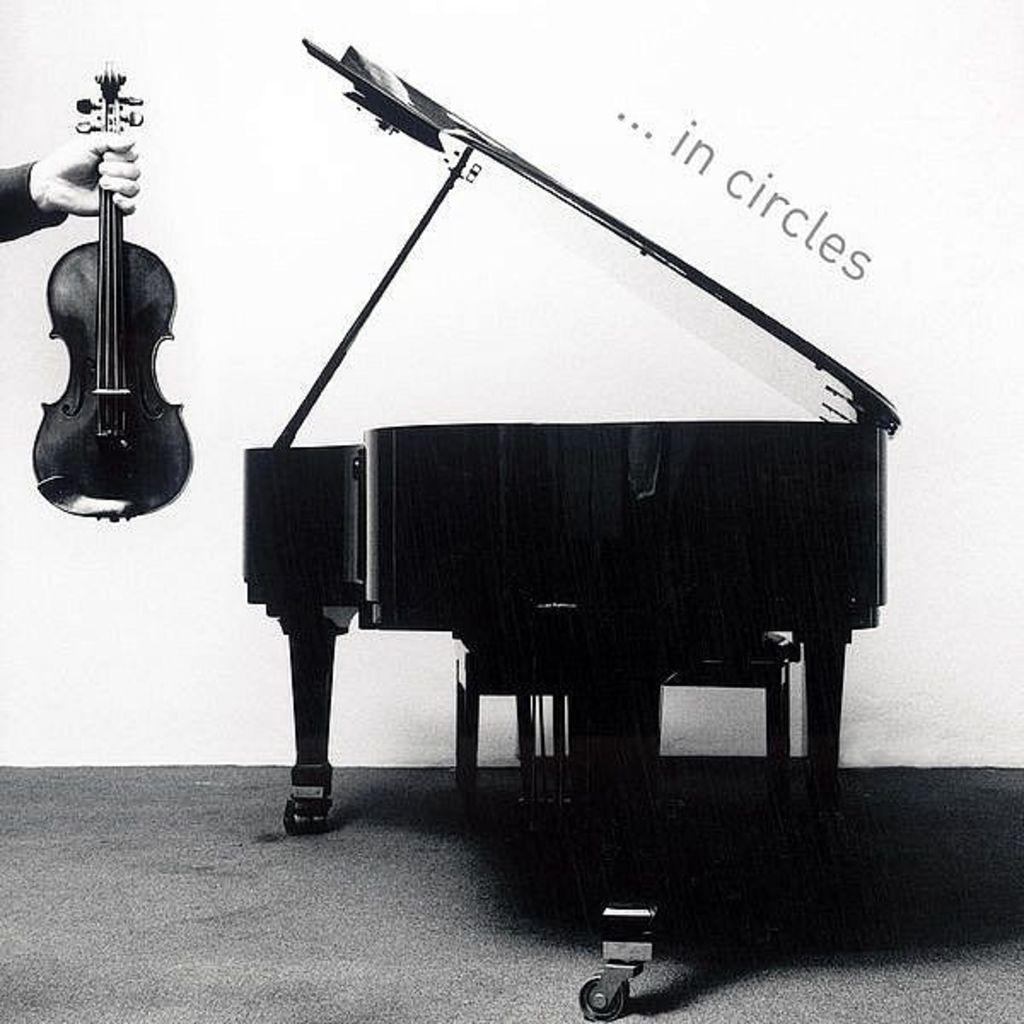What is the color scheme of the poster in the image? The poster is black and white. What musical instrument with wheels can be seen in the image? There is a piano with wheels in the image. What other musical instrument is present in the image? There is a violin in the image. Who is holding the violin in the image? A person is holding the violin. Where is the person holding the violin located in the image? The person is in the left corner of the image. What can be found on the poster besides the musical instruments? There is text written on the poster. Can you tell me how many cups are placed on the piano in the image? There are no cups present on the piano in the image. Is the person's grandmother playing the violin in the image? There is no mention of a grandmother in the image, and the person holding the violin is not playing it. 